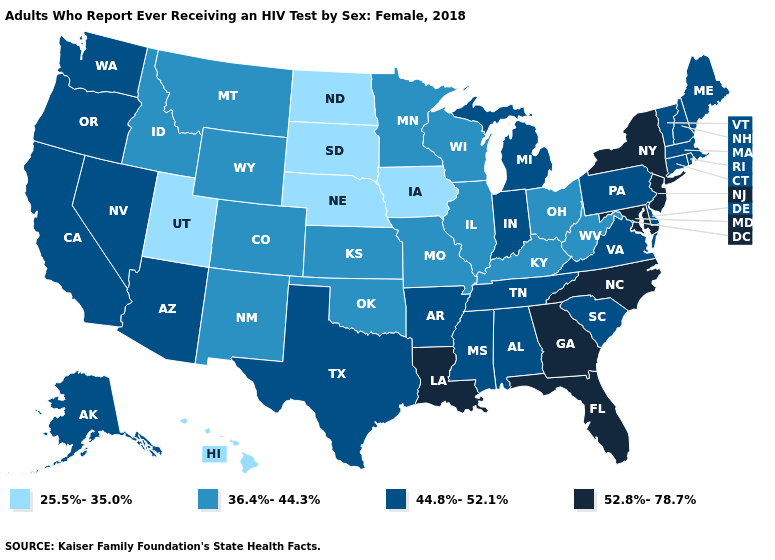Name the states that have a value in the range 25.5%-35.0%?
Quick response, please. Hawaii, Iowa, Nebraska, North Dakota, South Dakota, Utah. Among the states that border Vermont , which have the lowest value?
Answer briefly. Massachusetts, New Hampshire. Which states have the lowest value in the MidWest?
Concise answer only. Iowa, Nebraska, North Dakota, South Dakota. What is the highest value in the West ?
Keep it brief. 44.8%-52.1%. Which states hav the highest value in the MidWest?
Write a very short answer. Indiana, Michigan. What is the highest value in states that border New Hampshire?
Give a very brief answer. 44.8%-52.1%. Name the states that have a value in the range 36.4%-44.3%?
Quick response, please. Colorado, Idaho, Illinois, Kansas, Kentucky, Minnesota, Missouri, Montana, New Mexico, Ohio, Oklahoma, West Virginia, Wisconsin, Wyoming. Which states have the highest value in the USA?
Be succinct. Florida, Georgia, Louisiana, Maryland, New Jersey, New York, North Carolina. Name the states that have a value in the range 36.4%-44.3%?
Be succinct. Colorado, Idaho, Illinois, Kansas, Kentucky, Minnesota, Missouri, Montana, New Mexico, Ohio, Oklahoma, West Virginia, Wisconsin, Wyoming. What is the highest value in the South ?
Be succinct. 52.8%-78.7%. What is the lowest value in states that border Pennsylvania?
Answer briefly. 36.4%-44.3%. Name the states that have a value in the range 44.8%-52.1%?
Be succinct. Alabama, Alaska, Arizona, Arkansas, California, Connecticut, Delaware, Indiana, Maine, Massachusetts, Michigan, Mississippi, Nevada, New Hampshire, Oregon, Pennsylvania, Rhode Island, South Carolina, Tennessee, Texas, Vermont, Virginia, Washington. What is the value of Maine?
Keep it brief. 44.8%-52.1%. What is the lowest value in the West?
Concise answer only. 25.5%-35.0%. What is the value of Vermont?
Concise answer only. 44.8%-52.1%. 